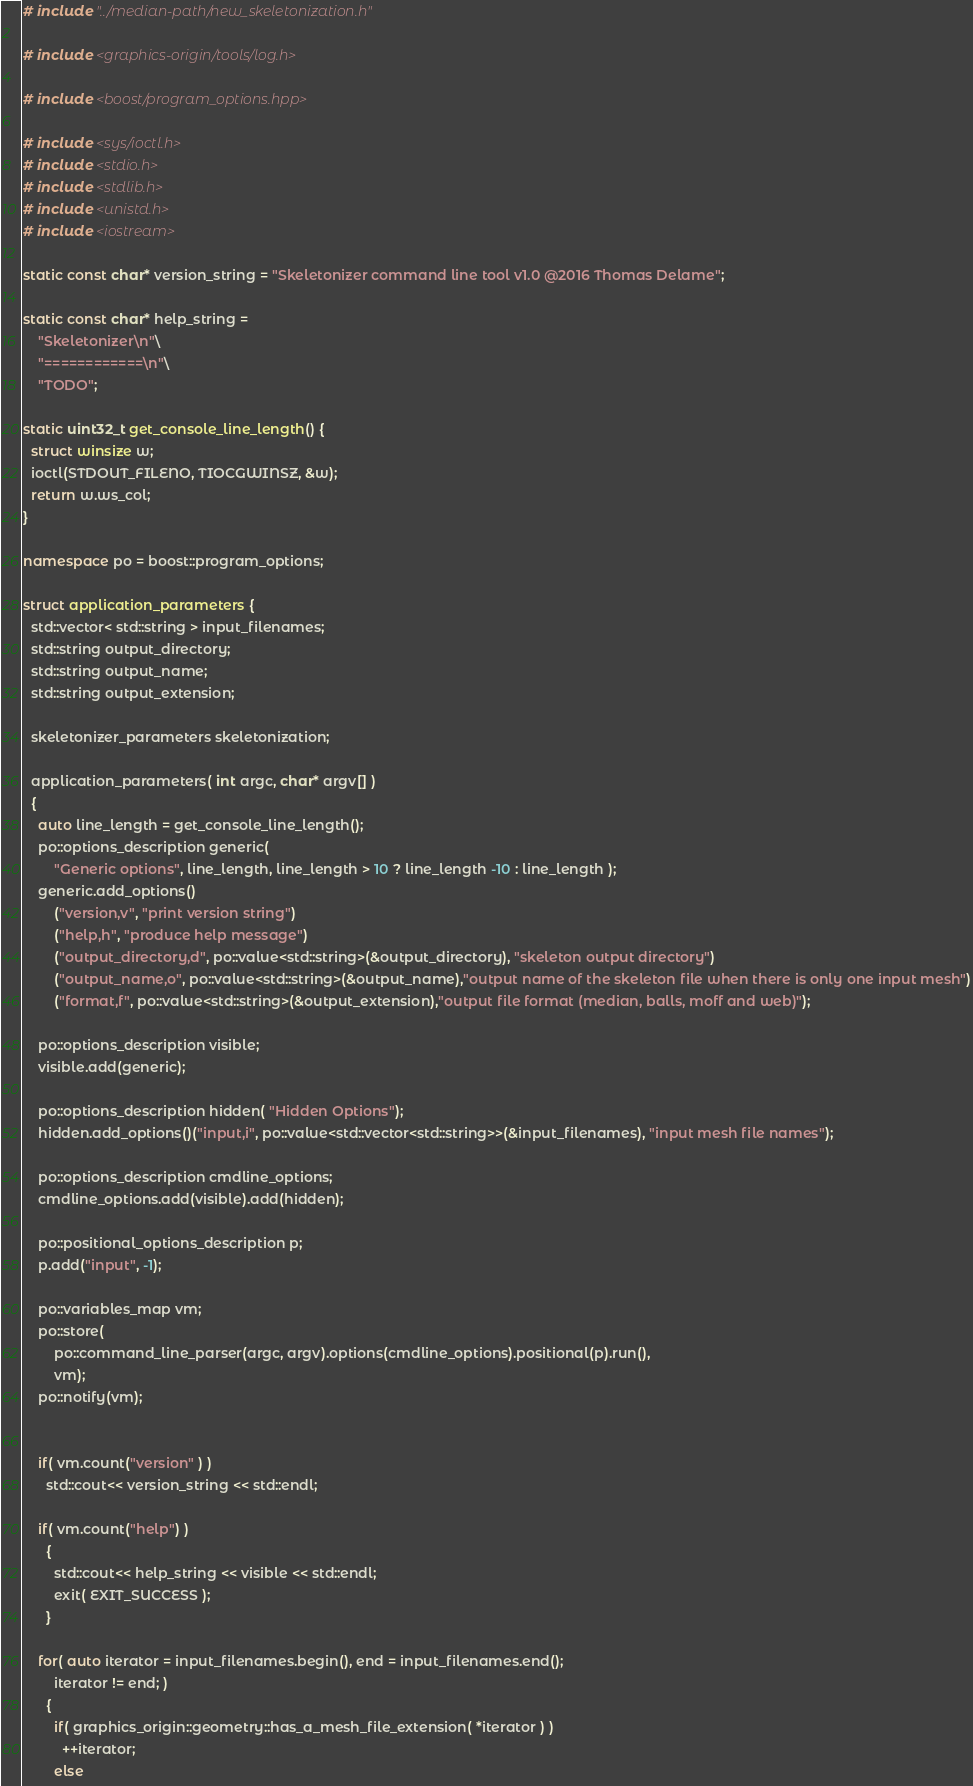<code> <loc_0><loc_0><loc_500><loc_500><_C++_># include "../median-path/new_skeletonization.h"

# include <graphics-origin/tools/log.h>

# include <boost/program_options.hpp>

# include <sys/ioctl.h>
# include <stdio.h>
# include <stdlib.h>
# include <unistd.h>
# include <iostream>

static const char* version_string = "Skeletonizer command line tool v1.0 @2016 Thomas Delame";

static const char* help_string =
    "Skeletonizer\n"\
    "============\n"\
    "TODO";

static uint32_t get_console_line_length() {
  struct winsize w;
  ioctl(STDOUT_FILENO, TIOCGWINSZ, &w);
  return w.ws_col;
}

namespace po = boost::program_options;

struct application_parameters {
  std::vector< std::string > input_filenames;
  std::string output_directory;
  std::string output_name;
  std::string output_extension;

  skeletonizer_parameters skeletonization;

  application_parameters( int argc, char* argv[] )
  {
    auto line_length = get_console_line_length();
    po::options_description generic(
        "Generic options", line_length, line_length > 10 ? line_length -10 : line_length );
    generic.add_options()
        ("version,v", "print version string")
        ("help,h", "produce help message")
        ("output_directory,d", po::value<std::string>(&output_directory), "skeleton output directory")
        ("output_name,o", po::value<std::string>(&output_name),"output name of the skeleton file when there is only one input mesh")
        ("format,f", po::value<std::string>(&output_extension),"output file format (median, balls, moff and web)");

    po::options_description visible;
    visible.add(generic);

    po::options_description hidden( "Hidden Options");
    hidden.add_options()("input,i", po::value<std::vector<std::string>>(&input_filenames), "input mesh file names");

    po::options_description cmdline_options;
    cmdline_options.add(visible).add(hidden);

    po::positional_options_description p;
    p.add("input", -1);

    po::variables_map vm;
    po::store(
        po::command_line_parser(argc, argv).options(cmdline_options).positional(p).run(),
        vm);
    po::notify(vm);


    if( vm.count("version" ) )
      std::cout<< version_string << std::endl;

    if( vm.count("help") )
      {
        std::cout<< help_string << visible << std::endl;
        exit( EXIT_SUCCESS );
      }

    for( auto iterator = input_filenames.begin(), end = input_filenames.end();
        iterator != end; )
      {
        if( graphics_origin::geometry::has_a_mesh_file_extension( *iterator ) )
          ++iterator;
        else</code> 